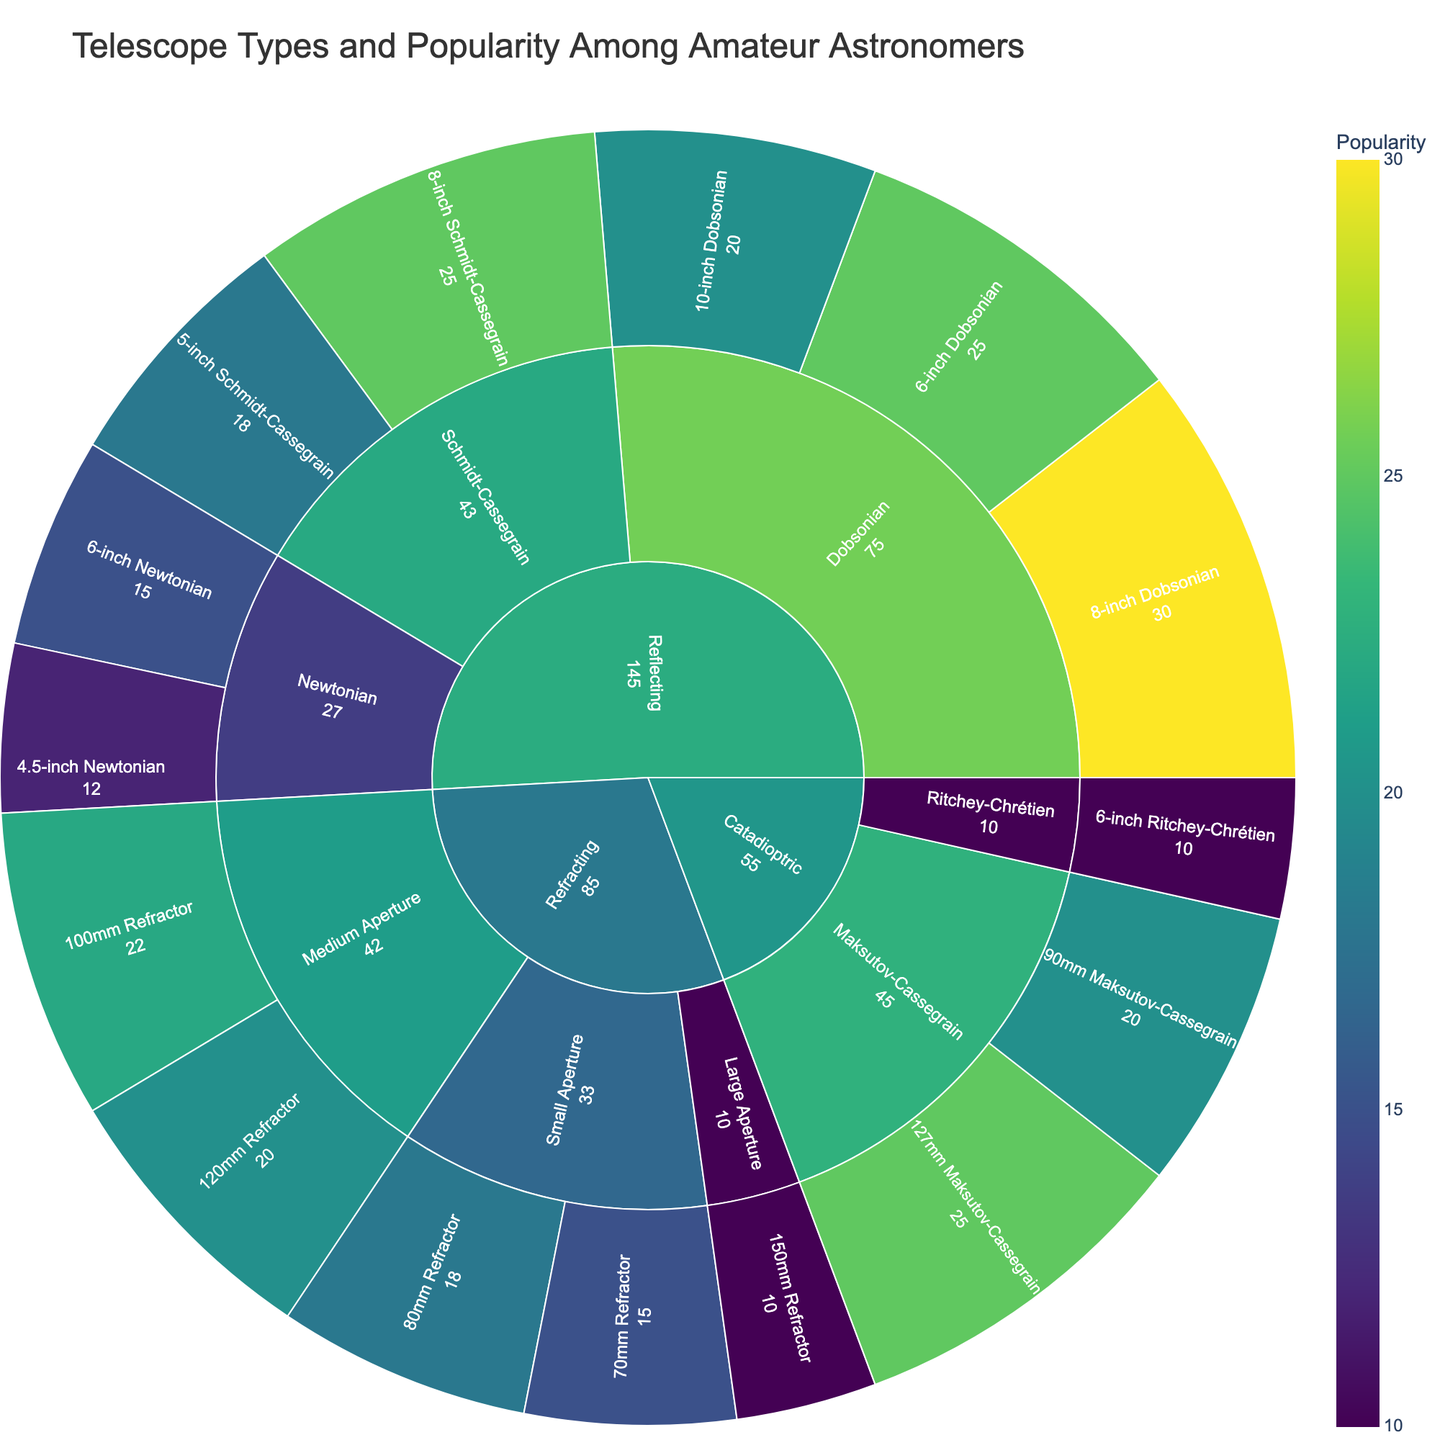what is the title of the plot? The title is typically found at the top center of the plot and provides a general idea about the content being presented. In this plot, it should state the focus on telescope types and popularity among amateur astronomers.
Answer: Telescope Types and Popularity Among Amateur Astronomers Which telescope type has the highest popularity? The size of each section in the Sunburst Plot corresponds to its popularity. The larger the segment, the more popular it is. The 8-inch Dobsonian in the Reflecting category has the largest segment.
Answer: 8-inch Dobsonian How many different subcategories are in the Refracting category? To find this, we look at the different segments branching out from the Refracting section in the plot. They represent different subcategories. Here, there are three subcategories: Small Aperture, Medium Aperture, and Large Aperture.
Answer: Three Which type of telescope in the Refracting category has the highest popularity? In the Refracting category, compare the popularity values of the various types: 70mm, 80mm, 100mm, 120mm, and 150mm Refractors. The highest value within this category is the 100mm Refractor with a popularity of 22.
Answer: 100mm Refractor Which category has the most types of telescopes listed? Count the number of different types of telescopes within each category: Refracting, Reflecting, and Catadioptric. The Reflecting category contains the most types.
Answer: Reflecting 